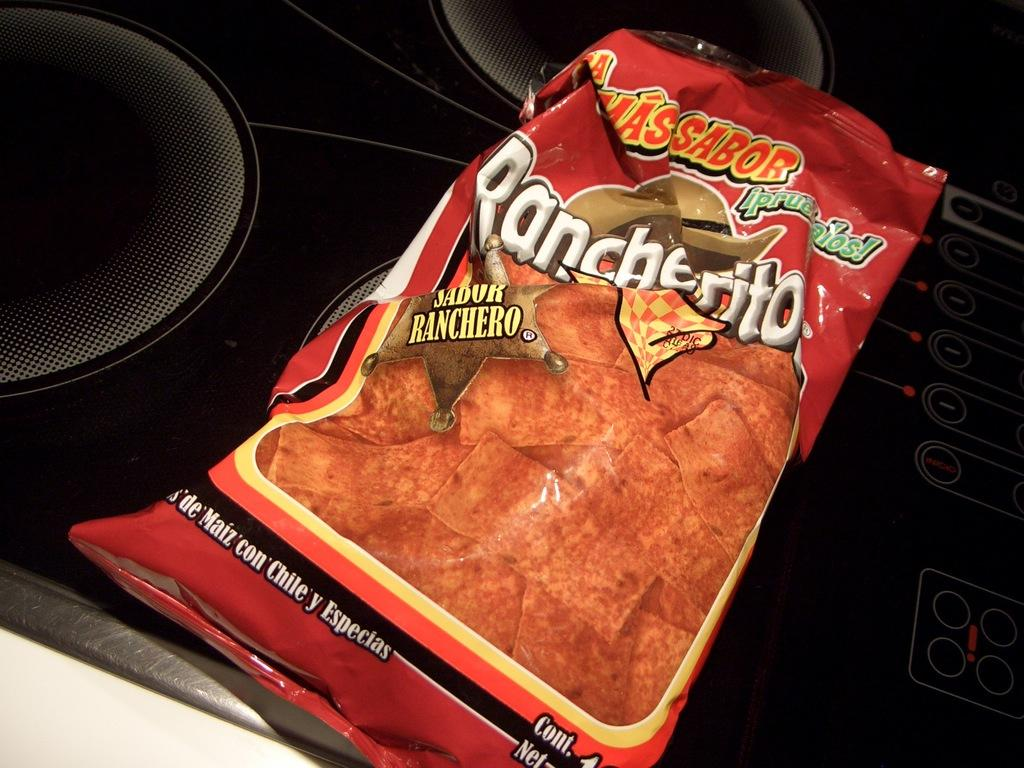What is present in the image that indicates someone has consumed a snack? There is a snacks wrapper in the image. What can be inferred about the person who left the wrapper in the image? The person who left the wrapper in the image has likely finished eating a snack. What might be a potential next step after disposing of the wrapper? The person might throw the wrapper away or recycle it. What form of transportation is depicted in the image? There is no form of transportation depicted in the image; it only contains a snacks wrapper. 